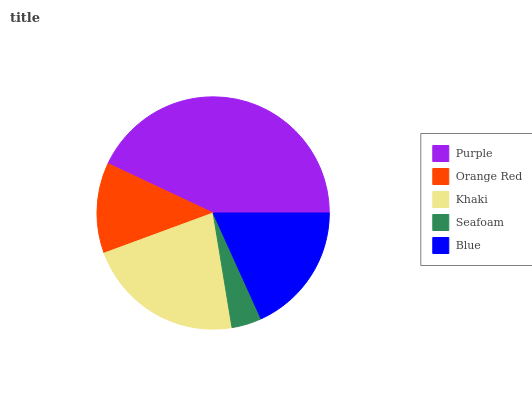Is Seafoam the minimum?
Answer yes or no. Yes. Is Purple the maximum?
Answer yes or no. Yes. Is Orange Red the minimum?
Answer yes or no. No. Is Orange Red the maximum?
Answer yes or no. No. Is Purple greater than Orange Red?
Answer yes or no. Yes. Is Orange Red less than Purple?
Answer yes or no. Yes. Is Orange Red greater than Purple?
Answer yes or no. No. Is Purple less than Orange Red?
Answer yes or no. No. Is Blue the high median?
Answer yes or no. Yes. Is Blue the low median?
Answer yes or no. Yes. Is Purple the high median?
Answer yes or no. No. Is Seafoam the low median?
Answer yes or no. No. 